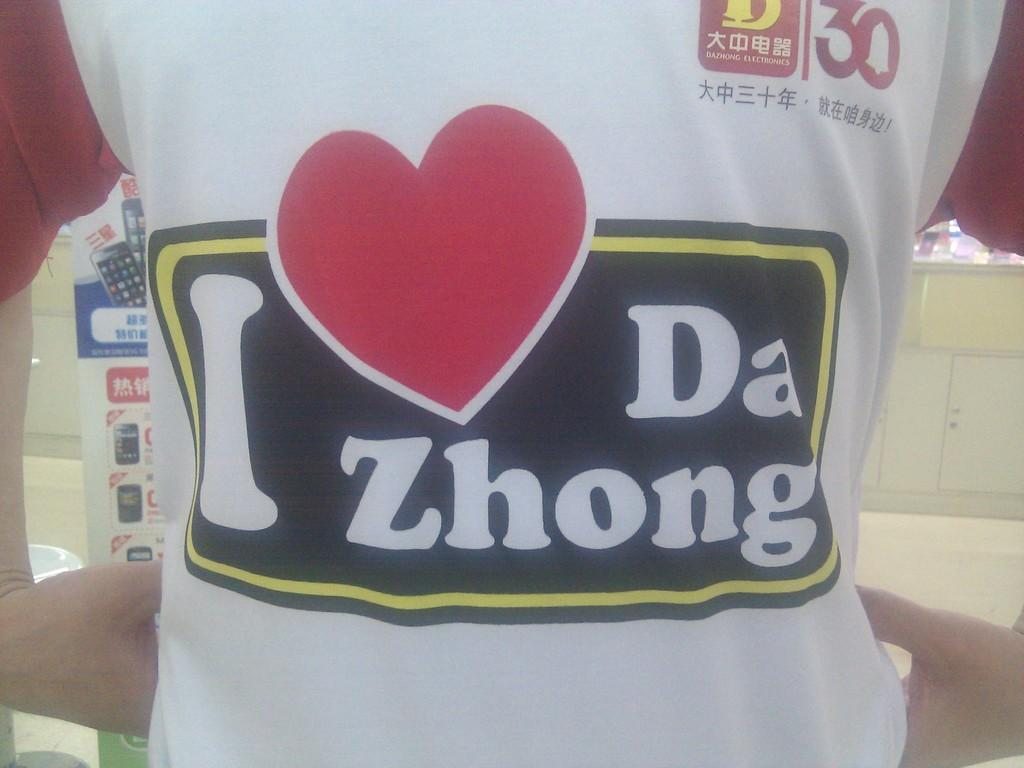<image>
Offer a succinct explanation of the picture presented. A person is wearing an I heart Da Zhong t-shirt. 